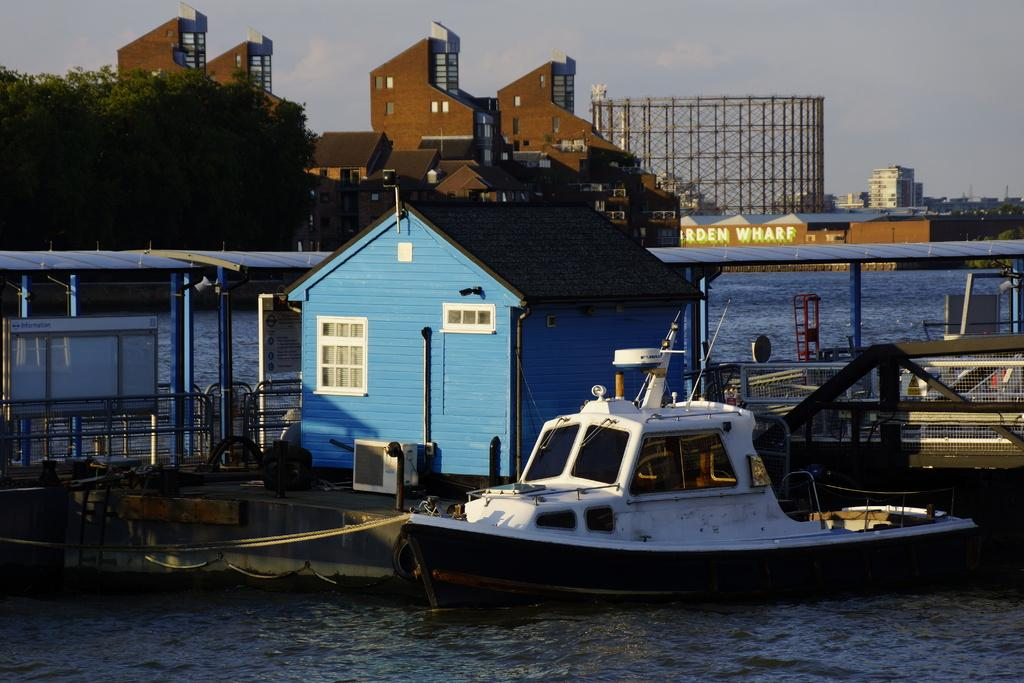What type of structures are visible in the image? There are buildings in the image. What natural elements can be seen in the image? There are trees in the image. What is located in the water in the image? There is a boat and a house in the water in the image. What is written or drawn on the wall of a building in the image? There is text on the wall of a building in the image. How would you describe the weather in the image? The sky is cloudy in the image. Can you tell me where the daughter is located in the image? There is no mention of a daughter in the image, so we cannot determine her location. What type of map is visible in the image? There is no map present in the image. 